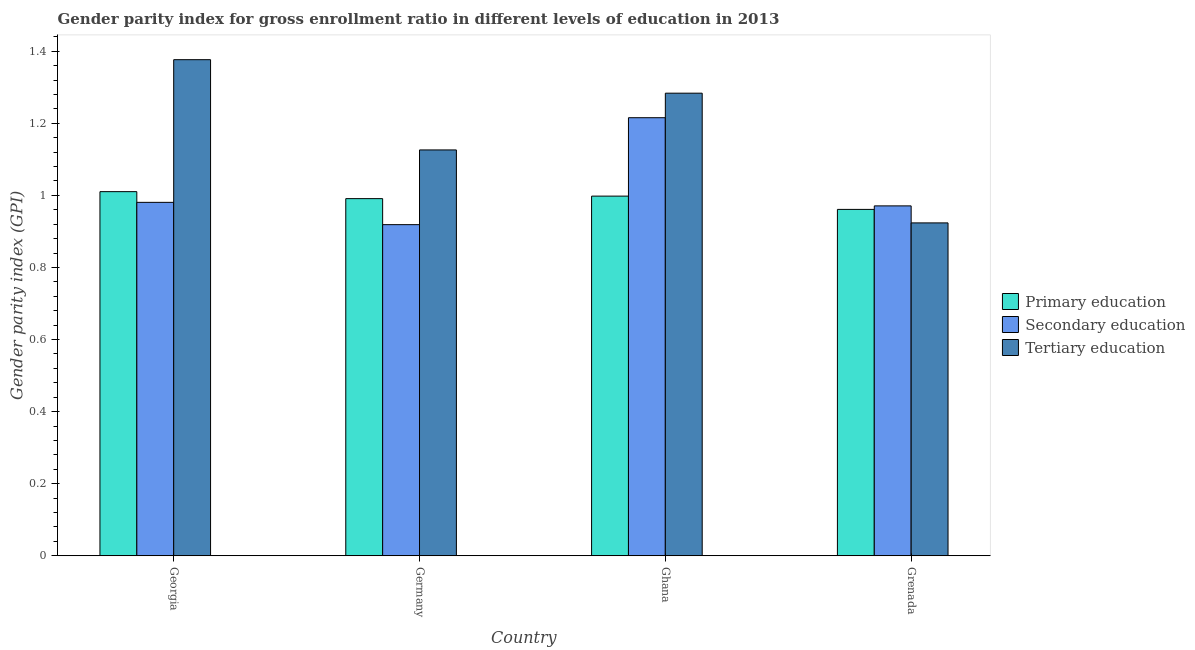How many different coloured bars are there?
Offer a very short reply. 3. Are the number of bars per tick equal to the number of legend labels?
Your answer should be very brief. Yes. How many bars are there on the 4th tick from the left?
Your answer should be compact. 3. How many bars are there on the 4th tick from the right?
Offer a terse response. 3. What is the label of the 4th group of bars from the left?
Keep it short and to the point. Grenada. In how many cases, is the number of bars for a given country not equal to the number of legend labels?
Your answer should be compact. 0. What is the gender parity index in tertiary education in Georgia?
Offer a terse response. 1.38. Across all countries, what is the maximum gender parity index in primary education?
Ensure brevity in your answer.  1.01. Across all countries, what is the minimum gender parity index in tertiary education?
Make the answer very short. 0.92. In which country was the gender parity index in tertiary education maximum?
Ensure brevity in your answer.  Georgia. What is the total gender parity index in secondary education in the graph?
Your answer should be compact. 4.09. What is the difference between the gender parity index in secondary education in Germany and that in Ghana?
Your response must be concise. -0.3. What is the difference between the gender parity index in secondary education in Grenada and the gender parity index in tertiary education in Germany?
Your answer should be very brief. -0.16. What is the average gender parity index in tertiary education per country?
Make the answer very short. 1.18. What is the difference between the gender parity index in secondary education and gender parity index in tertiary education in Germany?
Keep it short and to the point. -0.21. In how many countries, is the gender parity index in tertiary education greater than 0.56 ?
Your answer should be compact. 4. What is the ratio of the gender parity index in primary education in Germany to that in Grenada?
Provide a short and direct response. 1.03. Is the difference between the gender parity index in primary education in Georgia and Germany greater than the difference between the gender parity index in tertiary education in Georgia and Germany?
Your response must be concise. No. What is the difference between the highest and the second highest gender parity index in primary education?
Offer a terse response. 0.01. What is the difference between the highest and the lowest gender parity index in primary education?
Keep it short and to the point. 0.05. Is the sum of the gender parity index in secondary education in Germany and Ghana greater than the maximum gender parity index in tertiary education across all countries?
Keep it short and to the point. Yes. What does the 2nd bar from the right in Grenada represents?
Provide a succinct answer. Secondary education. How many bars are there?
Offer a very short reply. 12. Are all the bars in the graph horizontal?
Offer a terse response. No. How many countries are there in the graph?
Your answer should be compact. 4. Are the values on the major ticks of Y-axis written in scientific E-notation?
Your response must be concise. No. Does the graph contain any zero values?
Provide a short and direct response. No. Does the graph contain grids?
Your answer should be very brief. No. What is the title of the graph?
Make the answer very short. Gender parity index for gross enrollment ratio in different levels of education in 2013. Does "Oil sources" appear as one of the legend labels in the graph?
Provide a short and direct response. No. What is the label or title of the Y-axis?
Give a very brief answer. Gender parity index (GPI). What is the Gender parity index (GPI) of Primary education in Georgia?
Ensure brevity in your answer.  1.01. What is the Gender parity index (GPI) of Secondary education in Georgia?
Offer a very short reply. 0.98. What is the Gender parity index (GPI) of Tertiary education in Georgia?
Ensure brevity in your answer.  1.38. What is the Gender parity index (GPI) in Primary education in Germany?
Provide a short and direct response. 0.99. What is the Gender parity index (GPI) of Secondary education in Germany?
Make the answer very short. 0.92. What is the Gender parity index (GPI) of Tertiary education in Germany?
Make the answer very short. 1.13. What is the Gender parity index (GPI) in Primary education in Ghana?
Offer a terse response. 1. What is the Gender parity index (GPI) of Secondary education in Ghana?
Provide a short and direct response. 1.22. What is the Gender parity index (GPI) of Tertiary education in Ghana?
Your answer should be compact. 1.28. What is the Gender parity index (GPI) in Primary education in Grenada?
Keep it short and to the point. 0.96. What is the Gender parity index (GPI) in Secondary education in Grenada?
Offer a very short reply. 0.97. What is the Gender parity index (GPI) in Tertiary education in Grenada?
Offer a terse response. 0.92. Across all countries, what is the maximum Gender parity index (GPI) of Primary education?
Offer a very short reply. 1.01. Across all countries, what is the maximum Gender parity index (GPI) of Secondary education?
Keep it short and to the point. 1.22. Across all countries, what is the maximum Gender parity index (GPI) in Tertiary education?
Your response must be concise. 1.38. Across all countries, what is the minimum Gender parity index (GPI) in Primary education?
Offer a very short reply. 0.96. Across all countries, what is the minimum Gender parity index (GPI) in Secondary education?
Make the answer very short. 0.92. Across all countries, what is the minimum Gender parity index (GPI) of Tertiary education?
Your answer should be compact. 0.92. What is the total Gender parity index (GPI) in Primary education in the graph?
Offer a very short reply. 3.96. What is the total Gender parity index (GPI) of Secondary education in the graph?
Give a very brief answer. 4.09. What is the total Gender parity index (GPI) of Tertiary education in the graph?
Provide a short and direct response. 4.71. What is the difference between the Gender parity index (GPI) in Primary education in Georgia and that in Germany?
Keep it short and to the point. 0.02. What is the difference between the Gender parity index (GPI) in Secondary education in Georgia and that in Germany?
Provide a succinct answer. 0.06. What is the difference between the Gender parity index (GPI) of Tertiary education in Georgia and that in Germany?
Give a very brief answer. 0.25. What is the difference between the Gender parity index (GPI) in Primary education in Georgia and that in Ghana?
Offer a very short reply. 0.01. What is the difference between the Gender parity index (GPI) of Secondary education in Georgia and that in Ghana?
Keep it short and to the point. -0.23. What is the difference between the Gender parity index (GPI) of Tertiary education in Georgia and that in Ghana?
Your answer should be compact. 0.09. What is the difference between the Gender parity index (GPI) of Primary education in Georgia and that in Grenada?
Make the answer very short. 0.05. What is the difference between the Gender parity index (GPI) in Secondary education in Georgia and that in Grenada?
Your answer should be compact. 0.01. What is the difference between the Gender parity index (GPI) of Tertiary education in Georgia and that in Grenada?
Keep it short and to the point. 0.45. What is the difference between the Gender parity index (GPI) of Primary education in Germany and that in Ghana?
Your answer should be compact. -0.01. What is the difference between the Gender parity index (GPI) in Secondary education in Germany and that in Ghana?
Your answer should be compact. -0.3. What is the difference between the Gender parity index (GPI) in Tertiary education in Germany and that in Ghana?
Make the answer very short. -0.16. What is the difference between the Gender parity index (GPI) of Primary education in Germany and that in Grenada?
Your response must be concise. 0.03. What is the difference between the Gender parity index (GPI) of Secondary education in Germany and that in Grenada?
Your response must be concise. -0.05. What is the difference between the Gender parity index (GPI) of Tertiary education in Germany and that in Grenada?
Keep it short and to the point. 0.2. What is the difference between the Gender parity index (GPI) of Primary education in Ghana and that in Grenada?
Provide a short and direct response. 0.04. What is the difference between the Gender parity index (GPI) in Secondary education in Ghana and that in Grenada?
Keep it short and to the point. 0.24. What is the difference between the Gender parity index (GPI) in Tertiary education in Ghana and that in Grenada?
Make the answer very short. 0.36. What is the difference between the Gender parity index (GPI) of Primary education in Georgia and the Gender parity index (GPI) of Secondary education in Germany?
Keep it short and to the point. 0.09. What is the difference between the Gender parity index (GPI) in Primary education in Georgia and the Gender parity index (GPI) in Tertiary education in Germany?
Offer a very short reply. -0.12. What is the difference between the Gender parity index (GPI) in Secondary education in Georgia and the Gender parity index (GPI) in Tertiary education in Germany?
Provide a short and direct response. -0.15. What is the difference between the Gender parity index (GPI) in Primary education in Georgia and the Gender parity index (GPI) in Secondary education in Ghana?
Your response must be concise. -0.21. What is the difference between the Gender parity index (GPI) in Primary education in Georgia and the Gender parity index (GPI) in Tertiary education in Ghana?
Your response must be concise. -0.27. What is the difference between the Gender parity index (GPI) of Secondary education in Georgia and the Gender parity index (GPI) of Tertiary education in Ghana?
Offer a very short reply. -0.3. What is the difference between the Gender parity index (GPI) in Primary education in Georgia and the Gender parity index (GPI) in Secondary education in Grenada?
Ensure brevity in your answer.  0.04. What is the difference between the Gender parity index (GPI) of Primary education in Georgia and the Gender parity index (GPI) of Tertiary education in Grenada?
Provide a succinct answer. 0.09. What is the difference between the Gender parity index (GPI) in Secondary education in Georgia and the Gender parity index (GPI) in Tertiary education in Grenada?
Offer a terse response. 0.06. What is the difference between the Gender parity index (GPI) of Primary education in Germany and the Gender parity index (GPI) of Secondary education in Ghana?
Your answer should be very brief. -0.22. What is the difference between the Gender parity index (GPI) in Primary education in Germany and the Gender parity index (GPI) in Tertiary education in Ghana?
Offer a terse response. -0.29. What is the difference between the Gender parity index (GPI) in Secondary education in Germany and the Gender parity index (GPI) in Tertiary education in Ghana?
Your answer should be compact. -0.36. What is the difference between the Gender parity index (GPI) in Primary education in Germany and the Gender parity index (GPI) in Secondary education in Grenada?
Offer a terse response. 0.02. What is the difference between the Gender parity index (GPI) of Primary education in Germany and the Gender parity index (GPI) of Tertiary education in Grenada?
Give a very brief answer. 0.07. What is the difference between the Gender parity index (GPI) of Secondary education in Germany and the Gender parity index (GPI) of Tertiary education in Grenada?
Your answer should be very brief. -0. What is the difference between the Gender parity index (GPI) of Primary education in Ghana and the Gender parity index (GPI) of Secondary education in Grenada?
Provide a succinct answer. 0.03. What is the difference between the Gender parity index (GPI) in Primary education in Ghana and the Gender parity index (GPI) in Tertiary education in Grenada?
Offer a very short reply. 0.07. What is the difference between the Gender parity index (GPI) in Secondary education in Ghana and the Gender parity index (GPI) in Tertiary education in Grenada?
Your answer should be compact. 0.29. What is the average Gender parity index (GPI) of Primary education per country?
Give a very brief answer. 0.99. What is the average Gender parity index (GPI) in Secondary education per country?
Offer a very short reply. 1.02. What is the average Gender parity index (GPI) in Tertiary education per country?
Provide a succinct answer. 1.18. What is the difference between the Gender parity index (GPI) of Primary education and Gender parity index (GPI) of Secondary education in Georgia?
Provide a short and direct response. 0.03. What is the difference between the Gender parity index (GPI) of Primary education and Gender parity index (GPI) of Tertiary education in Georgia?
Give a very brief answer. -0.37. What is the difference between the Gender parity index (GPI) of Secondary education and Gender parity index (GPI) of Tertiary education in Georgia?
Make the answer very short. -0.4. What is the difference between the Gender parity index (GPI) of Primary education and Gender parity index (GPI) of Secondary education in Germany?
Your response must be concise. 0.07. What is the difference between the Gender parity index (GPI) of Primary education and Gender parity index (GPI) of Tertiary education in Germany?
Make the answer very short. -0.14. What is the difference between the Gender parity index (GPI) of Secondary education and Gender parity index (GPI) of Tertiary education in Germany?
Give a very brief answer. -0.21. What is the difference between the Gender parity index (GPI) of Primary education and Gender parity index (GPI) of Secondary education in Ghana?
Make the answer very short. -0.22. What is the difference between the Gender parity index (GPI) of Primary education and Gender parity index (GPI) of Tertiary education in Ghana?
Your response must be concise. -0.29. What is the difference between the Gender parity index (GPI) of Secondary education and Gender parity index (GPI) of Tertiary education in Ghana?
Your response must be concise. -0.07. What is the difference between the Gender parity index (GPI) in Primary education and Gender parity index (GPI) in Secondary education in Grenada?
Your answer should be very brief. -0.01. What is the difference between the Gender parity index (GPI) of Primary education and Gender parity index (GPI) of Tertiary education in Grenada?
Keep it short and to the point. 0.04. What is the difference between the Gender parity index (GPI) of Secondary education and Gender parity index (GPI) of Tertiary education in Grenada?
Keep it short and to the point. 0.05. What is the ratio of the Gender parity index (GPI) in Primary education in Georgia to that in Germany?
Your answer should be very brief. 1.02. What is the ratio of the Gender parity index (GPI) of Secondary education in Georgia to that in Germany?
Your answer should be very brief. 1.07. What is the ratio of the Gender parity index (GPI) of Tertiary education in Georgia to that in Germany?
Make the answer very short. 1.22. What is the ratio of the Gender parity index (GPI) in Primary education in Georgia to that in Ghana?
Make the answer very short. 1.01. What is the ratio of the Gender parity index (GPI) in Secondary education in Georgia to that in Ghana?
Provide a succinct answer. 0.81. What is the ratio of the Gender parity index (GPI) in Tertiary education in Georgia to that in Ghana?
Your response must be concise. 1.07. What is the ratio of the Gender parity index (GPI) in Primary education in Georgia to that in Grenada?
Your answer should be very brief. 1.05. What is the ratio of the Gender parity index (GPI) in Tertiary education in Georgia to that in Grenada?
Your response must be concise. 1.49. What is the ratio of the Gender parity index (GPI) of Secondary education in Germany to that in Ghana?
Provide a short and direct response. 0.76. What is the ratio of the Gender parity index (GPI) in Tertiary education in Germany to that in Ghana?
Make the answer very short. 0.88. What is the ratio of the Gender parity index (GPI) of Primary education in Germany to that in Grenada?
Offer a very short reply. 1.03. What is the ratio of the Gender parity index (GPI) of Secondary education in Germany to that in Grenada?
Your answer should be very brief. 0.95. What is the ratio of the Gender parity index (GPI) of Tertiary education in Germany to that in Grenada?
Give a very brief answer. 1.22. What is the ratio of the Gender parity index (GPI) of Primary education in Ghana to that in Grenada?
Your answer should be very brief. 1.04. What is the ratio of the Gender parity index (GPI) of Secondary education in Ghana to that in Grenada?
Your answer should be very brief. 1.25. What is the ratio of the Gender parity index (GPI) of Tertiary education in Ghana to that in Grenada?
Provide a short and direct response. 1.39. What is the difference between the highest and the second highest Gender parity index (GPI) of Primary education?
Your answer should be very brief. 0.01. What is the difference between the highest and the second highest Gender parity index (GPI) of Secondary education?
Your answer should be very brief. 0.23. What is the difference between the highest and the second highest Gender parity index (GPI) of Tertiary education?
Offer a very short reply. 0.09. What is the difference between the highest and the lowest Gender parity index (GPI) of Primary education?
Provide a succinct answer. 0.05. What is the difference between the highest and the lowest Gender parity index (GPI) in Secondary education?
Keep it short and to the point. 0.3. What is the difference between the highest and the lowest Gender parity index (GPI) in Tertiary education?
Provide a short and direct response. 0.45. 